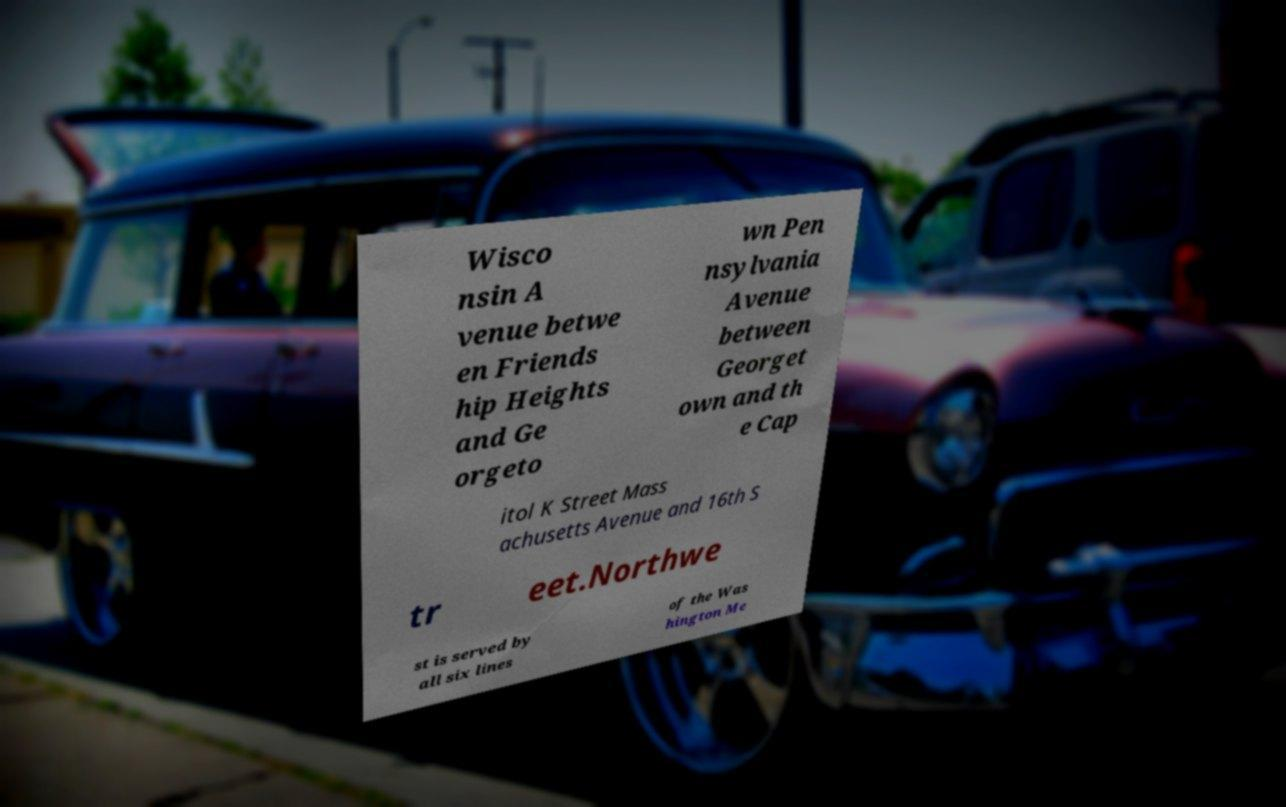There's text embedded in this image that I need extracted. Can you transcribe it verbatim? Wisco nsin A venue betwe en Friends hip Heights and Ge orgeto wn Pen nsylvania Avenue between Georget own and th e Cap itol K Street Mass achusetts Avenue and 16th S tr eet.Northwe st is served by all six lines of the Was hington Me 